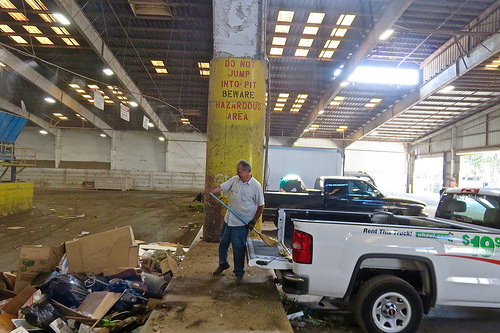<image>
Is there a car to the left of the man? No. The car is not to the left of the man. From this viewpoint, they have a different horizontal relationship. Where is the trash in relation to the truck? Is it behind the truck? Yes. From this viewpoint, the trash is positioned behind the truck, with the truck partially or fully occluding the trash. Is there a man behind the truck? Yes. From this viewpoint, the man is positioned behind the truck, with the truck partially or fully occluding the man. 